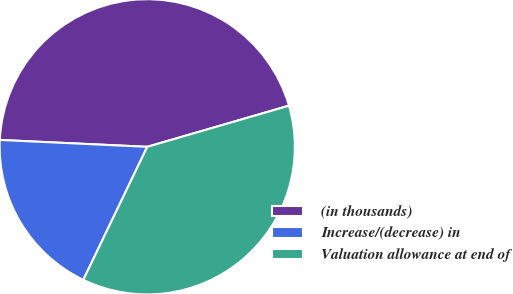Convert chart. <chart><loc_0><loc_0><loc_500><loc_500><pie_chart><fcel>(in thousands)<fcel>Increase/(decrease) in<fcel>Valuation allowance at end of<nl><fcel>44.76%<fcel>18.61%<fcel>36.63%<nl></chart> 